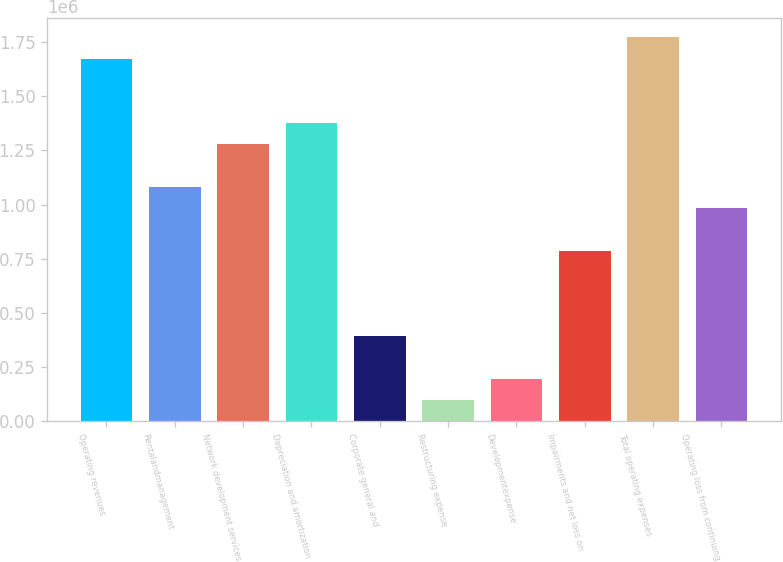Convert chart. <chart><loc_0><loc_0><loc_500><loc_500><bar_chart><fcel>Operating revenues<fcel>Rentalandmanagement<fcel>Network development services<fcel>Depreciation and amortization<fcel>Corporate general and<fcel>Restructuring expense<fcel>Developmentexpense<fcel>Impairments and net loss on<fcel>Total operating expenses<fcel>Operating loss from continuing<nl><fcel>1.67364e+06<fcel>1.08306e+06<fcel>1.27992e+06<fcel>1.37835e+06<fcel>394041<fcel>98748.8<fcel>197180<fcel>787764<fcel>1.77207e+06<fcel>984626<nl></chart> 